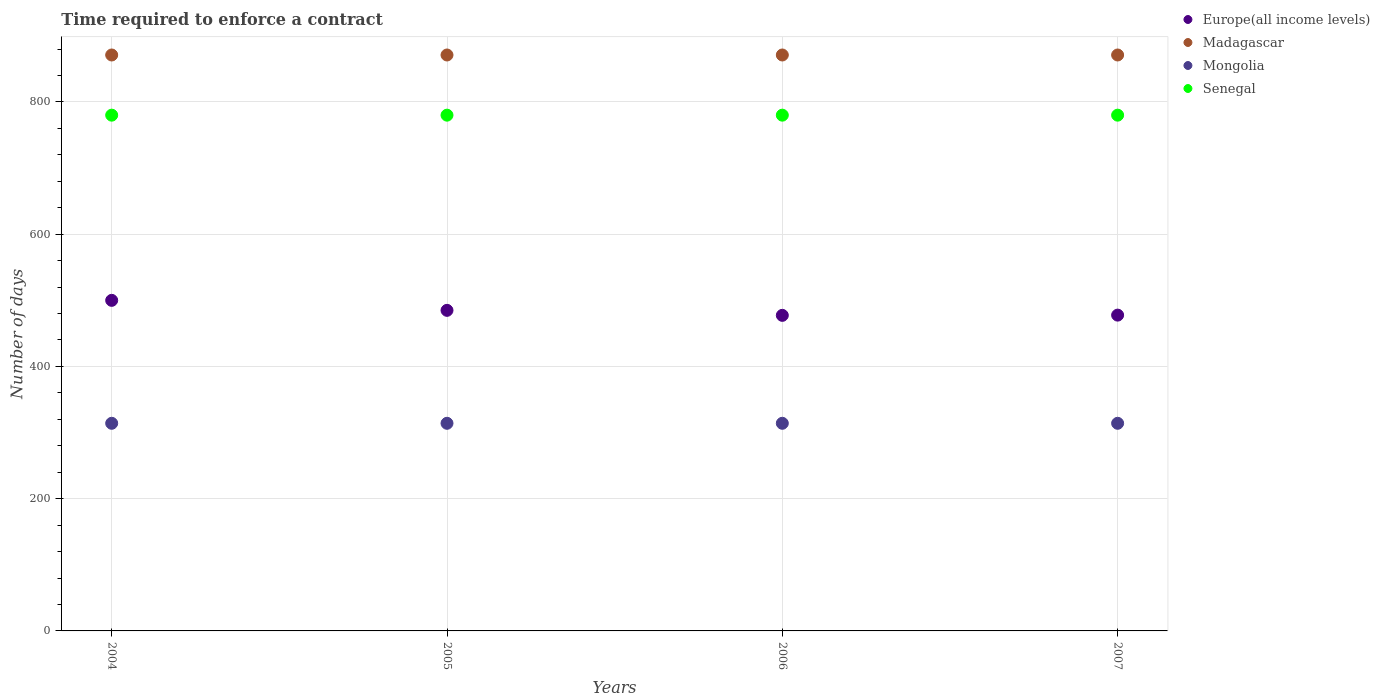Is the number of dotlines equal to the number of legend labels?
Offer a very short reply. Yes. What is the number of days required to enforce a contract in Madagascar in 2005?
Give a very brief answer. 871. Across all years, what is the maximum number of days required to enforce a contract in Europe(all income levels)?
Give a very brief answer. 499.93. Across all years, what is the minimum number of days required to enforce a contract in Europe(all income levels)?
Offer a terse response. 477.24. In which year was the number of days required to enforce a contract in Mongolia maximum?
Your answer should be very brief. 2004. What is the total number of days required to enforce a contract in Mongolia in the graph?
Give a very brief answer. 1256. What is the difference between the number of days required to enforce a contract in Europe(all income levels) in 2004 and that in 2005?
Your answer should be very brief. 15.11. What is the difference between the number of days required to enforce a contract in Europe(all income levels) in 2005 and the number of days required to enforce a contract in Senegal in 2007?
Keep it short and to the point. -295.19. What is the average number of days required to enforce a contract in Senegal per year?
Your response must be concise. 780. In the year 2005, what is the difference between the number of days required to enforce a contract in Europe(all income levels) and number of days required to enforce a contract in Senegal?
Ensure brevity in your answer.  -295.19. In how many years, is the number of days required to enforce a contract in Madagascar greater than 840 days?
Your answer should be very brief. 4. Is the number of days required to enforce a contract in Europe(all income levels) in 2006 less than that in 2007?
Make the answer very short. Yes. What is the difference between the highest and the second highest number of days required to enforce a contract in Mongolia?
Offer a terse response. 0. Is it the case that in every year, the sum of the number of days required to enforce a contract in Europe(all income levels) and number of days required to enforce a contract in Senegal  is greater than the number of days required to enforce a contract in Mongolia?
Your answer should be compact. Yes. Does the number of days required to enforce a contract in Europe(all income levels) monotonically increase over the years?
Provide a succinct answer. No. How many dotlines are there?
Provide a short and direct response. 4. How many years are there in the graph?
Your answer should be very brief. 4. Are the values on the major ticks of Y-axis written in scientific E-notation?
Provide a short and direct response. No. What is the title of the graph?
Your answer should be very brief. Time required to enforce a contract. What is the label or title of the X-axis?
Ensure brevity in your answer.  Years. What is the label or title of the Y-axis?
Your answer should be very brief. Number of days. What is the Number of days in Europe(all income levels) in 2004?
Your answer should be very brief. 499.93. What is the Number of days of Madagascar in 2004?
Your response must be concise. 871. What is the Number of days in Mongolia in 2004?
Keep it short and to the point. 314. What is the Number of days in Senegal in 2004?
Offer a very short reply. 780. What is the Number of days in Europe(all income levels) in 2005?
Give a very brief answer. 484.81. What is the Number of days of Madagascar in 2005?
Offer a terse response. 871. What is the Number of days of Mongolia in 2005?
Ensure brevity in your answer.  314. What is the Number of days in Senegal in 2005?
Give a very brief answer. 780. What is the Number of days in Europe(all income levels) in 2006?
Provide a short and direct response. 477.24. What is the Number of days in Madagascar in 2006?
Make the answer very short. 871. What is the Number of days of Mongolia in 2006?
Give a very brief answer. 314. What is the Number of days in Senegal in 2006?
Your answer should be compact. 780. What is the Number of days in Europe(all income levels) in 2007?
Give a very brief answer. 477.6. What is the Number of days of Madagascar in 2007?
Give a very brief answer. 871. What is the Number of days in Mongolia in 2007?
Make the answer very short. 314. What is the Number of days in Senegal in 2007?
Keep it short and to the point. 780. Across all years, what is the maximum Number of days of Europe(all income levels)?
Your response must be concise. 499.93. Across all years, what is the maximum Number of days of Madagascar?
Provide a succinct answer. 871. Across all years, what is the maximum Number of days of Mongolia?
Keep it short and to the point. 314. Across all years, what is the maximum Number of days of Senegal?
Your answer should be compact. 780. Across all years, what is the minimum Number of days of Europe(all income levels)?
Your answer should be very brief. 477.24. Across all years, what is the minimum Number of days in Madagascar?
Keep it short and to the point. 871. Across all years, what is the minimum Number of days of Mongolia?
Keep it short and to the point. 314. Across all years, what is the minimum Number of days in Senegal?
Your response must be concise. 780. What is the total Number of days of Europe(all income levels) in the graph?
Ensure brevity in your answer.  1939.59. What is the total Number of days of Madagascar in the graph?
Your answer should be very brief. 3484. What is the total Number of days of Mongolia in the graph?
Your answer should be very brief. 1256. What is the total Number of days of Senegal in the graph?
Offer a terse response. 3120. What is the difference between the Number of days of Europe(all income levels) in 2004 and that in 2005?
Keep it short and to the point. 15.11. What is the difference between the Number of days in Mongolia in 2004 and that in 2005?
Make the answer very short. 0. What is the difference between the Number of days of Senegal in 2004 and that in 2005?
Offer a terse response. 0. What is the difference between the Number of days in Europe(all income levels) in 2004 and that in 2006?
Your response must be concise. 22.68. What is the difference between the Number of days of Mongolia in 2004 and that in 2006?
Provide a succinct answer. 0. What is the difference between the Number of days in Europe(all income levels) in 2004 and that in 2007?
Ensure brevity in your answer.  22.33. What is the difference between the Number of days in Senegal in 2004 and that in 2007?
Offer a very short reply. 0. What is the difference between the Number of days in Europe(all income levels) in 2005 and that in 2006?
Keep it short and to the point. 7.57. What is the difference between the Number of days in Mongolia in 2005 and that in 2006?
Provide a succinct answer. 0. What is the difference between the Number of days of Senegal in 2005 and that in 2006?
Your answer should be very brief. 0. What is the difference between the Number of days of Europe(all income levels) in 2005 and that in 2007?
Your response must be concise. 7.21. What is the difference between the Number of days in Madagascar in 2005 and that in 2007?
Give a very brief answer. 0. What is the difference between the Number of days in Mongolia in 2005 and that in 2007?
Your answer should be compact. 0. What is the difference between the Number of days of Senegal in 2005 and that in 2007?
Make the answer very short. 0. What is the difference between the Number of days in Europe(all income levels) in 2006 and that in 2007?
Make the answer very short. -0.36. What is the difference between the Number of days of Madagascar in 2006 and that in 2007?
Offer a terse response. 0. What is the difference between the Number of days of Mongolia in 2006 and that in 2007?
Offer a very short reply. 0. What is the difference between the Number of days in Senegal in 2006 and that in 2007?
Ensure brevity in your answer.  0. What is the difference between the Number of days of Europe(all income levels) in 2004 and the Number of days of Madagascar in 2005?
Make the answer very short. -371.07. What is the difference between the Number of days of Europe(all income levels) in 2004 and the Number of days of Mongolia in 2005?
Your answer should be very brief. 185.93. What is the difference between the Number of days in Europe(all income levels) in 2004 and the Number of days in Senegal in 2005?
Provide a short and direct response. -280.07. What is the difference between the Number of days in Madagascar in 2004 and the Number of days in Mongolia in 2005?
Keep it short and to the point. 557. What is the difference between the Number of days in Madagascar in 2004 and the Number of days in Senegal in 2005?
Give a very brief answer. 91. What is the difference between the Number of days in Mongolia in 2004 and the Number of days in Senegal in 2005?
Offer a terse response. -466. What is the difference between the Number of days of Europe(all income levels) in 2004 and the Number of days of Madagascar in 2006?
Make the answer very short. -371.07. What is the difference between the Number of days in Europe(all income levels) in 2004 and the Number of days in Mongolia in 2006?
Your answer should be compact. 185.93. What is the difference between the Number of days in Europe(all income levels) in 2004 and the Number of days in Senegal in 2006?
Provide a short and direct response. -280.07. What is the difference between the Number of days in Madagascar in 2004 and the Number of days in Mongolia in 2006?
Your answer should be compact. 557. What is the difference between the Number of days of Madagascar in 2004 and the Number of days of Senegal in 2006?
Your response must be concise. 91. What is the difference between the Number of days of Mongolia in 2004 and the Number of days of Senegal in 2006?
Make the answer very short. -466. What is the difference between the Number of days in Europe(all income levels) in 2004 and the Number of days in Madagascar in 2007?
Provide a short and direct response. -371.07. What is the difference between the Number of days of Europe(all income levels) in 2004 and the Number of days of Mongolia in 2007?
Offer a terse response. 185.93. What is the difference between the Number of days of Europe(all income levels) in 2004 and the Number of days of Senegal in 2007?
Keep it short and to the point. -280.07. What is the difference between the Number of days in Madagascar in 2004 and the Number of days in Mongolia in 2007?
Provide a succinct answer. 557. What is the difference between the Number of days of Madagascar in 2004 and the Number of days of Senegal in 2007?
Your response must be concise. 91. What is the difference between the Number of days in Mongolia in 2004 and the Number of days in Senegal in 2007?
Offer a terse response. -466. What is the difference between the Number of days in Europe(all income levels) in 2005 and the Number of days in Madagascar in 2006?
Offer a very short reply. -386.19. What is the difference between the Number of days in Europe(all income levels) in 2005 and the Number of days in Mongolia in 2006?
Offer a terse response. 170.81. What is the difference between the Number of days in Europe(all income levels) in 2005 and the Number of days in Senegal in 2006?
Offer a terse response. -295.19. What is the difference between the Number of days of Madagascar in 2005 and the Number of days of Mongolia in 2006?
Offer a very short reply. 557. What is the difference between the Number of days in Madagascar in 2005 and the Number of days in Senegal in 2006?
Your response must be concise. 91. What is the difference between the Number of days of Mongolia in 2005 and the Number of days of Senegal in 2006?
Make the answer very short. -466. What is the difference between the Number of days of Europe(all income levels) in 2005 and the Number of days of Madagascar in 2007?
Provide a succinct answer. -386.19. What is the difference between the Number of days of Europe(all income levels) in 2005 and the Number of days of Mongolia in 2007?
Give a very brief answer. 170.81. What is the difference between the Number of days in Europe(all income levels) in 2005 and the Number of days in Senegal in 2007?
Your answer should be very brief. -295.19. What is the difference between the Number of days of Madagascar in 2005 and the Number of days of Mongolia in 2007?
Give a very brief answer. 557. What is the difference between the Number of days of Madagascar in 2005 and the Number of days of Senegal in 2007?
Ensure brevity in your answer.  91. What is the difference between the Number of days of Mongolia in 2005 and the Number of days of Senegal in 2007?
Provide a succinct answer. -466. What is the difference between the Number of days of Europe(all income levels) in 2006 and the Number of days of Madagascar in 2007?
Your answer should be very brief. -393.76. What is the difference between the Number of days of Europe(all income levels) in 2006 and the Number of days of Mongolia in 2007?
Provide a succinct answer. 163.24. What is the difference between the Number of days of Europe(all income levels) in 2006 and the Number of days of Senegal in 2007?
Your answer should be very brief. -302.76. What is the difference between the Number of days in Madagascar in 2006 and the Number of days in Mongolia in 2007?
Keep it short and to the point. 557. What is the difference between the Number of days of Madagascar in 2006 and the Number of days of Senegal in 2007?
Your response must be concise. 91. What is the difference between the Number of days in Mongolia in 2006 and the Number of days in Senegal in 2007?
Your response must be concise. -466. What is the average Number of days in Europe(all income levels) per year?
Your answer should be compact. 484.9. What is the average Number of days in Madagascar per year?
Make the answer very short. 871. What is the average Number of days of Mongolia per year?
Ensure brevity in your answer.  314. What is the average Number of days of Senegal per year?
Keep it short and to the point. 780. In the year 2004, what is the difference between the Number of days of Europe(all income levels) and Number of days of Madagascar?
Ensure brevity in your answer.  -371.07. In the year 2004, what is the difference between the Number of days in Europe(all income levels) and Number of days in Mongolia?
Your answer should be compact. 185.93. In the year 2004, what is the difference between the Number of days of Europe(all income levels) and Number of days of Senegal?
Ensure brevity in your answer.  -280.07. In the year 2004, what is the difference between the Number of days in Madagascar and Number of days in Mongolia?
Keep it short and to the point. 557. In the year 2004, what is the difference between the Number of days in Madagascar and Number of days in Senegal?
Ensure brevity in your answer.  91. In the year 2004, what is the difference between the Number of days of Mongolia and Number of days of Senegal?
Provide a succinct answer. -466. In the year 2005, what is the difference between the Number of days of Europe(all income levels) and Number of days of Madagascar?
Offer a terse response. -386.19. In the year 2005, what is the difference between the Number of days of Europe(all income levels) and Number of days of Mongolia?
Give a very brief answer. 170.81. In the year 2005, what is the difference between the Number of days of Europe(all income levels) and Number of days of Senegal?
Ensure brevity in your answer.  -295.19. In the year 2005, what is the difference between the Number of days of Madagascar and Number of days of Mongolia?
Provide a succinct answer. 557. In the year 2005, what is the difference between the Number of days of Madagascar and Number of days of Senegal?
Provide a succinct answer. 91. In the year 2005, what is the difference between the Number of days of Mongolia and Number of days of Senegal?
Make the answer very short. -466. In the year 2006, what is the difference between the Number of days in Europe(all income levels) and Number of days in Madagascar?
Make the answer very short. -393.76. In the year 2006, what is the difference between the Number of days of Europe(all income levels) and Number of days of Mongolia?
Your answer should be very brief. 163.24. In the year 2006, what is the difference between the Number of days in Europe(all income levels) and Number of days in Senegal?
Your answer should be compact. -302.76. In the year 2006, what is the difference between the Number of days in Madagascar and Number of days in Mongolia?
Ensure brevity in your answer.  557. In the year 2006, what is the difference between the Number of days in Madagascar and Number of days in Senegal?
Offer a terse response. 91. In the year 2006, what is the difference between the Number of days of Mongolia and Number of days of Senegal?
Offer a very short reply. -466. In the year 2007, what is the difference between the Number of days in Europe(all income levels) and Number of days in Madagascar?
Give a very brief answer. -393.4. In the year 2007, what is the difference between the Number of days of Europe(all income levels) and Number of days of Mongolia?
Offer a terse response. 163.6. In the year 2007, what is the difference between the Number of days in Europe(all income levels) and Number of days in Senegal?
Provide a short and direct response. -302.4. In the year 2007, what is the difference between the Number of days in Madagascar and Number of days in Mongolia?
Give a very brief answer. 557. In the year 2007, what is the difference between the Number of days of Madagascar and Number of days of Senegal?
Your answer should be compact. 91. In the year 2007, what is the difference between the Number of days in Mongolia and Number of days in Senegal?
Your response must be concise. -466. What is the ratio of the Number of days of Europe(all income levels) in 2004 to that in 2005?
Offer a terse response. 1.03. What is the ratio of the Number of days in Europe(all income levels) in 2004 to that in 2006?
Give a very brief answer. 1.05. What is the ratio of the Number of days in Mongolia in 2004 to that in 2006?
Ensure brevity in your answer.  1. What is the ratio of the Number of days in Senegal in 2004 to that in 2006?
Your response must be concise. 1. What is the ratio of the Number of days in Europe(all income levels) in 2004 to that in 2007?
Provide a short and direct response. 1.05. What is the ratio of the Number of days in Mongolia in 2004 to that in 2007?
Provide a short and direct response. 1. What is the ratio of the Number of days of Europe(all income levels) in 2005 to that in 2006?
Provide a succinct answer. 1.02. What is the ratio of the Number of days in Madagascar in 2005 to that in 2006?
Provide a succinct answer. 1. What is the ratio of the Number of days of Mongolia in 2005 to that in 2006?
Make the answer very short. 1. What is the ratio of the Number of days of Senegal in 2005 to that in 2006?
Your answer should be very brief. 1. What is the ratio of the Number of days of Europe(all income levels) in 2005 to that in 2007?
Offer a very short reply. 1.02. What is the ratio of the Number of days in Madagascar in 2005 to that in 2007?
Offer a very short reply. 1. What is the difference between the highest and the second highest Number of days in Europe(all income levels)?
Keep it short and to the point. 15.11. What is the difference between the highest and the second highest Number of days in Mongolia?
Ensure brevity in your answer.  0. What is the difference between the highest and the lowest Number of days of Europe(all income levels)?
Keep it short and to the point. 22.68. What is the difference between the highest and the lowest Number of days in Madagascar?
Offer a terse response. 0. 